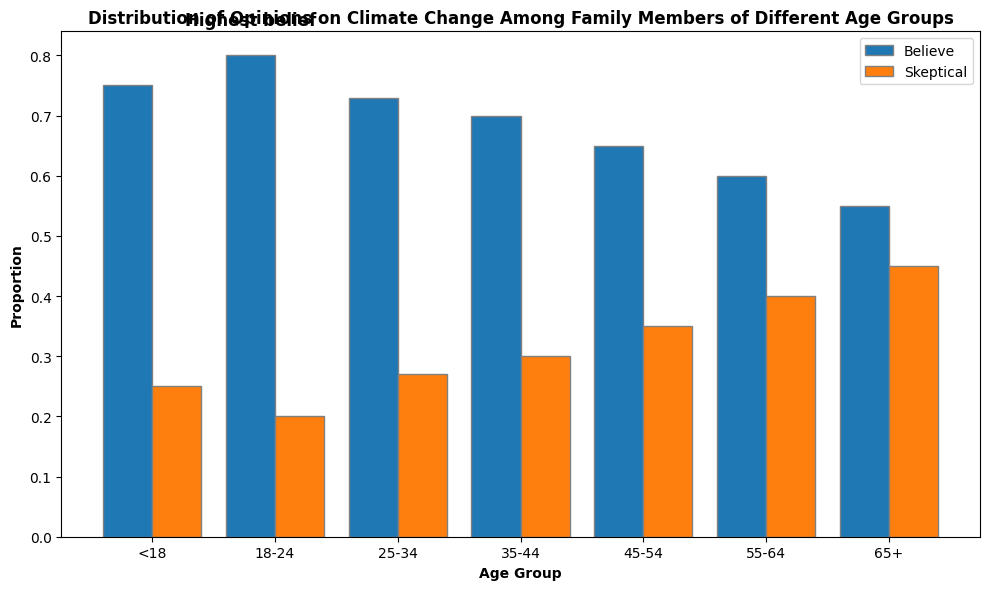What age group has the highest proportion believing in climate change? Identify the bar with the highest value for "Proportion Believe". The highest bar in blue is the age group of 18-24.
Answer: 18-24 What is the difference in proportion between those who believe and are skeptical in the 65+ age group? Locate the proportions for the 65+ age group: 0.55 (believe) and 0.45 (skeptical). Subtract 0.45 from 0.55.
Answer: 0.10 Which age group shows the highest proportion of skepticism towards climate change? Identify the bar with the highest value for "Proportion Skeptical". The highest bar in orange is the 65+ age group.
Answer: 65+ What is the average proportion of belief in climate change across all age groups? Sum proportions of belief across all age groups, then divide by the number of groups: (0.75 + 0.80 + 0.73 + 0.70 + 0.65 + 0.60 + 0.55) / 7.
Answer: 0.6829 Which two age groups have the same proportion of skepticism towards climate change? Compare proportions in the orange bars to find matching values: both the 18-24 and <18 age groups show a 0.20 proportion of skepticism.
Answer: <18 and 18-24 Is the proportion of belief in climate change greater than the proportion of skepticism in the 35-44 age group? Compare the proportions for the 35-44 age group: 0.70 (believe) and 0.30 (skeptical).
Answer: Yes What is the average proportion of skepticism in climate change for the age groups 45-54 and 55-64? Add the proportions for 45-54 (0.35) and 55-64 (0.40), then divide by 2.
Answer: 0.375 Which age group's belief proportion is closest to 0.70? Identify the age group whose belief proportion is closest to 0.70. The 25-34 age group's proportion is 0.73.
Answer: 25-34 What does the text annotation 'Highest belief' refer to? The annotation highlights the highest proportion of belief in any age group, which is 0.80 in the 18-24 age group.
Answer: 18-24 age group 